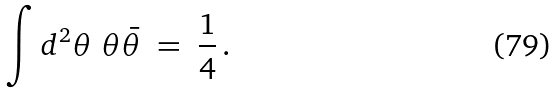Convert formula to latex. <formula><loc_0><loc_0><loc_500><loc_500>\int d ^ { 2 } \theta \ \theta \bar { \theta } \ = \ \frac { 1 } { 4 } \, .</formula> 